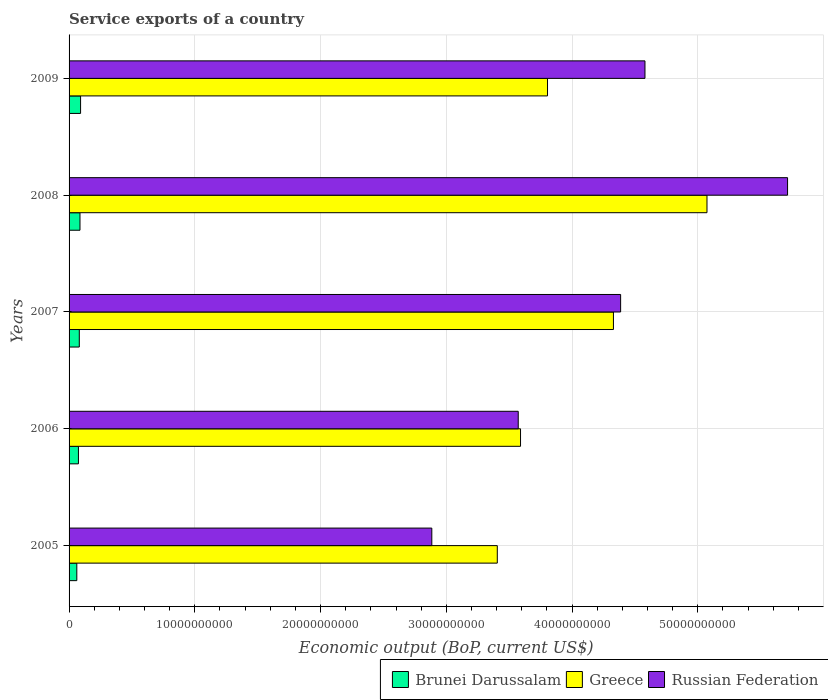How many different coloured bars are there?
Provide a short and direct response. 3. How many bars are there on the 1st tick from the bottom?
Ensure brevity in your answer.  3. In how many cases, is the number of bars for a given year not equal to the number of legend labels?
Offer a terse response. 0. What is the service exports in Greece in 2009?
Your answer should be very brief. 3.80e+1. Across all years, what is the maximum service exports in Greece?
Your response must be concise. 5.07e+1. Across all years, what is the minimum service exports in Brunei Darussalam?
Provide a short and direct response. 6.16e+08. What is the total service exports in Brunei Darussalam in the graph?
Give a very brief answer. 3.96e+09. What is the difference between the service exports in Russian Federation in 2005 and that in 2009?
Make the answer very short. -1.70e+1. What is the difference between the service exports in Russian Federation in 2005 and the service exports in Brunei Darussalam in 2009?
Ensure brevity in your answer.  2.79e+1. What is the average service exports in Brunei Darussalam per year?
Give a very brief answer. 7.91e+08. In the year 2006, what is the difference between the service exports in Brunei Darussalam and service exports in Russian Federation?
Give a very brief answer. -3.50e+1. What is the ratio of the service exports in Brunei Darussalam in 2006 to that in 2009?
Your answer should be very brief. 0.81. Is the service exports in Russian Federation in 2005 less than that in 2006?
Your answer should be compact. Yes. Is the difference between the service exports in Brunei Darussalam in 2008 and 2009 greater than the difference between the service exports in Russian Federation in 2008 and 2009?
Give a very brief answer. No. What is the difference between the highest and the second highest service exports in Brunei Darussalam?
Your response must be concise. 4.77e+07. What is the difference between the highest and the lowest service exports in Greece?
Your response must be concise. 1.67e+1. In how many years, is the service exports in Russian Federation greater than the average service exports in Russian Federation taken over all years?
Keep it short and to the point. 3. Is the sum of the service exports in Russian Federation in 2005 and 2007 greater than the maximum service exports in Greece across all years?
Offer a very short reply. Yes. What does the 1st bar from the top in 2008 represents?
Give a very brief answer. Russian Federation. What does the 3rd bar from the bottom in 2007 represents?
Make the answer very short. Russian Federation. Is it the case that in every year, the sum of the service exports in Brunei Darussalam and service exports in Russian Federation is greater than the service exports in Greece?
Your answer should be very brief. No. How many bars are there?
Keep it short and to the point. 15. Are all the bars in the graph horizontal?
Make the answer very short. Yes. Does the graph contain any zero values?
Give a very brief answer. No. What is the title of the graph?
Your response must be concise. Service exports of a country. Does "Canada" appear as one of the legend labels in the graph?
Offer a very short reply. No. What is the label or title of the X-axis?
Give a very brief answer. Economic output (BoP, current US$). What is the Economic output (BoP, current US$) in Brunei Darussalam in 2005?
Your response must be concise. 6.16e+08. What is the Economic output (BoP, current US$) of Greece in 2005?
Your answer should be compact. 3.41e+1. What is the Economic output (BoP, current US$) of Russian Federation in 2005?
Ensure brevity in your answer.  2.88e+1. What is the Economic output (BoP, current US$) in Brunei Darussalam in 2006?
Offer a very short reply. 7.45e+08. What is the Economic output (BoP, current US$) in Greece in 2006?
Your answer should be compact. 3.59e+1. What is the Economic output (BoP, current US$) in Russian Federation in 2006?
Your answer should be very brief. 3.57e+1. What is the Economic output (BoP, current US$) of Brunei Darussalam in 2007?
Your answer should be very brief. 8.13e+08. What is the Economic output (BoP, current US$) of Greece in 2007?
Provide a short and direct response. 4.33e+1. What is the Economic output (BoP, current US$) in Russian Federation in 2007?
Your answer should be very brief. 4.39e+1. What is the Economic output (BoP, current US$) of Brunei Darussalam in 2008?
Make the answer very short. 8.67e+08. What is the Economic output (BoP, current US$) in Greece in 2008?
Give a very brief answer. 5.07e+1. What is the Economic output (BoP, current US$) in Russian Federation in 2008?
Your response must be concise. 5.71e+1. What is the Economic output (BoP, current US$) in Brunei Darussalam in 2009?
Your response must be concise. 9.15e+08. What is the Economic output (BoP, current US$) in Greece in 2009?
Keep it short and to the point. 3.80e+1. What is the Economic output (BoP, current US$) of Russian Federation in 2009?
Provide a short and direct response. 4.58e+1. Across all years, what is the maximum Economic output (BoP, current US$) of Brunei Darussalam?
Provide a succinct answer. 9.15e+08. Across all years, what is the maximum Economic output (BoP, current US$) in Greece?
Provide a short and direct response. 5.07e+1. Across all years, what is the maximum Economic output (BoP, current US$) of Russian Federation?
Offer a terse response. 5.71e+1. Across all years, what is the minimum Economic output (BoP, current US$) in Brunei Darussalam?
Offer a terse response. 6.16e+08. Across all years, what is the minimum Economic output (BoP, current US$) in Greece?
Ensure brevity in your answer.  3.41e+1. Across all years, what is the minimum Economic output (BoP, current US$) of Russian Federation?
Provide a succinct answer. 2.88e+1. What is the total Economic output (BoP, current US$) of Brunei Darussalam in the graph?
Offer a terse response. 3.96e+09. What is the total Economic output (BoP, current US$) of Greece in the graph?
Provide a succinct answer. 2.02e+11. What is the total Economic output (BoP, current US$) in Russian Federation in the graph?
Your answer should be compact. 2.11e+11. What is the difference between the Economic output (BoP, current US$) in Brunei Darussalam in 2005 and that in 2006?
Provide a succinct answer. -1.28e+08. What is the difference between the Economic output (BoP, current US$) in Greece in 2005 and that in 2006?
Provide a short and direct response. -1.85e+09. What is the difference between the Economic output (BoP, current US$) in Russian Federation in 2005 and that in 2006?
Provide a short and direct response. -6.87e+09. What is the difference between the Economic output (BoP, current US$) of Brunei Darussalam in 2005 and that in 2007?
Provide a succinct answer. -1.97e+08. What is the difference between the Economic output (BoP, current US$) in Greece in 2005 and that in 2007?
Offer a terse response. -9.24e+09. What is the difference between the Economic output (BoP, current US$) of Russian Federation in 2005 and that in 2007?
Your answer should be compact. -1.50e+1. What is the difference between the Economic output (BoP, current US$) in Brunei Darussalam in 2005 and that in 2008?
Your answer should be compact. -2.51e+08. What is the difference between the Economic output (BoP, current US$) of Greece in 2005 and that in 2008?
Provide a short and direct response. -1.67e+1. What is the difference between the Economic output (BoP, current US$) of Russian Federation in 2005 and that in 2008?
Offer a very short reply. -2.83e+1. What is the difference between the Economic output (BoP, current US$) of Brunei Darussalam in 2005 and that in 2009?
Make the answer very short. -2.99e+08. What is the difference between the Economic output (BoP, current US$) in Greece in 2005 and that in 2009?
Keep it short and to the point. -3.99e+09. What is the difference between the Economic output (BoP, current US$) of Russian Federation in 2005 and that in 2009?
Give a very brief answer. -1.70e+1. What is the difference between the Economic output (BoP, current US$) of Brunei Darussalam in 2006 and that in 2007?
Keep it short and to the point. -6.88e+07. What is the difference between the Economic output (BoP, current US$) of Greece in 2006 and that in 2007?
Your answer should be very brief. -7.39e+09. What is the difference between the Economic output (BoP, current US$) of Russian Federation in 2006 and that in 2007?
Provide a short and direct response. -8.14e+09. What is the difference between the Economic output (BoP, current US$) in Brunei Darussalam in 2006 and that in 2008?
Your response must be concise. -1.23e+08. What is the difference between the Economic output (BoP, current US$) in Greece in 2006 and that in 2008?
Your answer should be very brief. -1.48e+1. What is the difference between the Economic output (BoP, current US$) of Russian Federation in 2006 and that in 2008?
Provide a succinct answer. -2.14e+1. What is the difference between the Economic output (BoP, current US$) of Brunei Darussalam in 2006 and that in 2009?
Your response must be concise. -1.70e+08. What is the difference between the Economic output (BoP, current US$) in Greece in 2006 and that in 2009?
Keep it short and to the point. -2.15e+09. What is the difference between the Economic output (BoP, current US$) in Russian Federation in 2006 and that in 2009?
Offer a terse response. -1.01e+1. What is the difference between the Economic output (BoP, current US$) of Brunei Darussalam in 2007 and that in 2008?
Give a very brief answer. -5.39e+07. What is the difference between the Economic output (BoP, current US$) in Greece in 2007 and that in 2008?
Your answer should be very brief. -7.44e+09. What is the difference between the Economic output (BoP, current US$) in Russian Federation in 2007 and that in 2008?
Offer a terse response. -1.33e+1. What is the difference between the Economic output (BoP, current US$) in Brunei Darussalam in 2007 and that in 2009?
Make the answer very short. -1.02e+08. What is the difference between the Economic output (BoP, current US$) of Greece in 2007 and that in 2009?
Provide a short and direct response. 5.24e+09. What is the difference between the Economic output (BoP, current US$) of Russian Federation in 2007 and that in 2009?
Keep it short and to the point. -1.94e+09. What is the difference between the Economic output (BoP, current US$) of Brunei Darussalam in 2008 and that in 2009?
Keep it short and to the point. -4.77e+07. What is the difference between the Economic output (BoP, current US$) of Greece in 2008 and that in 2009?
Your answer should be compact. 1.27e+1. What is the difference between the Economic output (BoP, current US$) of Russian Federation in 2008 and that in 2009?
Offer a terse response. 1.13e+1. What is the difference between the Economic output (BoP, current US$) of Brunei Darussalam in 2005 and the Economic output (BoP, current US$) of Greece in 2006?
Your response must be concise. -3.53e+1. What is the difference between the Economic output (BoP, current US$) of Brunei Darussalam in 2005 and the Economic output (BoP, current US$) of Russian Federation in 2006?
Your response must be concise. -3.51e+1. What is the difference between the Economic output (BoP, current US$) in Greece in 2005 and the Economic output (BoP, current US$) in Russian Federation in 2006?
Make the answer very short. -1.67e+09. What is the difference between the Economic output (BoP, current US$) in Brunei Darussalam in 2005 and the Economic output (BoP, current US$) in Greece in 2007?
Make the answer very short. -4.27e+1. What is the difference between the Economic output (BoP, current US$) in Brunei Darussalam in 2005 and the Economic output (BoP, current US$) in Russian Federation in 2007?
Your answer should be very brief. -4.32e+1. What is the difference between the Economic output (BoP, current US$) in Greece in 2005 and the Economic output (BoP, current US$) in Russian Federation in 2007?
Provide a succinct answer. -9.81e+09. What is the difference between the Economic output (BoP, current US$) in Brunei Darussalam in 2005 and the Economic output (BoP, current US$) in Greece in 2008?
Keep it short and to the point. -5.01e+1. What is the difference between the Economic output (BoP, current US$) in Brunei Darussalam in 2005 and the Economic output (BoP, current US$) in Russian Federation in 2008?
Ensure brevity in your answer.  -5.65e+1. What is the difference between the Economic output (BoP, current US$) in Greece in 2005 and the Economic output (BoP, current US$) in Russian Federation in 2008?
Give a very brief answer. -2.31e+1. What is the difference between the Economic output (BoP, current US$) of Brunei Darussalam in 2005 and the Economic output (BoP, current US$) of Greece in 2009?
Your response must be concise. -3.74e+1. What is the difference between the Economic output (BoP, current US$) in Brunei Darussalam in 2005 and the Economic output (BoP, current US$) in Russian Federation in 2009?
Keep it short and to the point. -4.52e+1. What is the difference between the Economic output (BoP, current US$) in Greece in 2005 and the Economic output (BoP, current US$) in Russian Federation in 2009?
Provide a succinct answer. -1.17e+1. What is the difference between the Economic output (BoP, current US$) in Brunei Darussalam in 2006 and the Economic output (BoP, current US$) in Greece in 2007?
Keep it short and to the point. -4.25e+1. What is the difference between the Economic output (BoP, current US$) of Brunei Darussalam in 2006 and the Economic output (BoP, current US$) of Russian Federation in 2007?
Offer a very short reply. -4.31e+1. What is the difference between the Economic output (BoP, current US$) of Greece in 2006 and the Economic output (BoP, current US$) of Russian Federation in 2007?
Your response must be concise. -7.96e+09. What is the difference between the Economic output (BoP, current US$) of Brunei Darussalam in 2006 and the Economic output (BoP, current US$) of Greece in 2008?
Your answer should be compact. -5.00e+1. What is the difference between the Economic output (BoP, current US$) of Brunei Darussalam in 2006 and the Economic output (BoP, current US$) of Russian Federation in 2008?
Offer a terse response. -5.64e+1. What is the difference between the Economic output (BoP, current US$) in Greece in 2006 and the Economic output (BoP, current US$) in Russian Federation in 2008?
Provide a short and direct response. -2.12e+1. What is the difference between the Economic output (BoP, current US$) of Brunei Darussalam in 2006 and the Economic output (BoP, current US$) of Greece in 2009?
Your answer should be very brief. -3.73e+1. What is the difference between the Economic output (BoP, current US$) in Brunei Darussalam in 2006 and the Economic output (BoP, current US$) in Russian Federation in 2009?
Your response must be concise. -4.51e+1. What is the difference between the Economic output (BoP, current US$) of Greece in 2006 and the Economic output (BoP, current US$) of Russian Federation in 2009?
Ensure brevity in your answer.  -9.90e+09. What is the difference between the Economic output (BoP, current US$) of Brunei Darussalam in 2007 and the Economic output (BoP, current US$) of Greece in 2008?
Ensure brevity in your answer.  -4.99e+1. What is the difference between the Economic output (BoP, current US$) of Brunei Darussalam in 2007 and the Economic output (BoP, current US$) of Russian Federation in 2008?
Ensure brevity in your answer.  -5.63e+1. What is the difference between the Economic output (BoP, current US$) of Greece in 2007 and the Economic output (BoP, current US$) of Russian Federation in 2008?
Keep it short and to the point. -1.38e+1. What is the difference between the Economic output (BoP, current US$) in Brunei Darussalam in 2007 and the Economic output (BoP, current US$) in Greece in 2009?
Give a very brief answer. -3.72e+1. What is the difference between the Economic output (BoP, current US$) of Brunei Darussalam in 2007 and the Economic output (BoP, current US$) of Russian Federation in 2009?
Your answer should be very brief. -4.50e+1. What is the difference between the Economic output (BoP, current US$) of Greece in 2007 and the Economic output (BoP, current US$) of Russian Federation in 2009?
Give a very brief answer. -2.51e+09. What is the difference between the Economic output (BoP, current US$) of Brunei Darussalam in 2008 and the Economic output (BoP, current US$) of Greece in 2009?
Make the answer very short. -3.72e+1. What is the difference between the Economic output (BoP, current US$) of Brunei Darussalam in 2008 and the Economic output (BoP, current US$) of Russian Federation in 2009?
Provide a succinct answer. -4.49e+1. What is the difference between the Economic output (BoP, current US$) of Greece in 2008 and the Economic output (BoP, current US$) of Russian Federation in 2009?
Keep it short and to the point. 4.93e+09. What is the average Economic output (BoP, current US$) of Brunei Darussalam per year?
Ensure brevity in your answer.  7.91e+08. What is the average Economic output (BoP, current US$) of Greece per year?
Your answer should be compact. 4.04e+1. What is the average Economic output (BoP, current US$) of Russian Federation per year?
Provide a short and direct response. 4.23e+1. In the year 2005, what is the difference between the Economic output (BoP, current US$) of Brunei Darussalam and Economic output (BoP, current US$) of Greece?
Your response must be concise. -3.34e+1. In the year 2005, what is the difference between the Economic output (BoP, current US$) in Brunei Darussalam and Economic output (BoP, current US$) in Russian Federation?
Provide a succinct answer. -2.82e+1. In the year 2005, what is the difference between the Economic output (BoP, current US$) in Greece and Economic output (BoP, current US$) in Russian Federation?
Offer a very short reply. 5.21e+09. In the year 2006, what is the difference between the Economic output (BoP, current US$) of Brunei Darussalam and Economic output (BoP, current US$) of Greece?
Keep it short and to the point. -3.52e+1. In the year 2006, what is the difference between the Economic output (BoP, current US$) of Brunei Darussalam and Economic output (BoP, current US$) of Russian Federation?
Ensure brevity in your answer.  -3.50e+1. In the year 2006, what is the difference between the Economic output (BoP, current US$) of Greece and Economic output (BoP, current US$) of Russian Federation?
Your answer should be compact. 1.82e+08. In the year 2007, what is the difference between the Economic output (BoP, current US$) in Brunei Darussalam and Economic output (BoP, current US$) in Greece?
Provide a short and direct response. -4.25e+1. In the year 2007, what is the difference between the Economic output (BoP, current US$) of Brunei Darussalam and Economic output (BoP, current US$) of Russian Federation?
Offer a very short reply. -4.30e+1. In the year 2007, what is the difference between the Economic output (BoP, current US$) in Greece and Economic output (BoP, current US$) in Russian Federation?
Your answer should be very brief. -5.71e+08. In the year 2008, what is the difference between the Economic output (BoP, current US$) in Brunei Darussalam and Economic output (BoP, current US$) in Greece?
Offer a terse response. -4.99e+1. In the year 2008, what is the difference between the Economic output (BoP, current US$) of Brunei Darussalam and Economic output (BoP, current US$) of Russian Federation?
Provide a short and direct response. -5.63e+1. In the year 2008, what is the difference between the Economic output (BoP, current US$) of Greece and Economic output (BoP, current US$) of Russian Federation?
Your response must be concise. -6.41e+09. In the year 2009, what is the difference between the Economic output (BoP, current US$) in Brunei Darussalam and Economic output (BoP, current US$) in Greece?
Your response must be concise. -3.71e+1. In the year 2009, what is the difference between the Economic output (BoP, current US$) in Brunei Darussalam and Economic output (BoP, current US$) in Russian Federation?
Offer a terse response. -4.49e+1. In the year 2009, what is the difference between the Economic output (BoP, current US$) in Greece and Economic output (BoP, current US$) in Russian Federation?
Offer a very short reply. -7.75e+09. What is the ratio of the Economic output (BoP, current US$) of Brunei Darussalam in 2005 to that in 2006?
Give a very brief answer. 0.83. What is the ratio of the Economic output (BoP, current US$) in Greece in 2005 to that in 2006?
Provide a short and direct response. 0.95. What is the ratio of the Economic output (BoP, current US$) of Russian Federation in 2005 to that in 2006?
Offer a very short reply. 0.81. What is the ratio of the Economic output (BoP, current US$) of Brunei Darussalam in 2005 to that in 2007?
Give a very brief answer. 0.76. What is the ratio of the Economic output (BoP, current US$) of Greece in 2005 to that in 2007?
Keep it short and to the point. 0.79. What is the ratio of the Economic output (BoP, current US$) of Russian Federation in 2005 to that in 2007?
Provide a short and direct response. 0.66. What is the ratio of the Economic output (BoP, current US$) of Brunei Darussalam in 2005 to that in 2008?
Offer a terse response. 0.71. What is the ratio of the Economic output (BoP, current US$) in Greece in 2005 to that in 2008?
Provide a succinct answer. 0.67. What is the ratio of the Economic output (BoP, current US$) of Russian Federation in 2005 to that in 2008?
Make the answer very short. 0.5. What is the ratio of the Economic output (BoP, current US$) of Brunei Darussalam in 2005 to that in 2009?
Provide a succinct answer. 0.67. What is the ratio of the Economic output (BoP, current US$) of Greece in 2005 to that in 2009?
Keep it short and to the point. 0.9. What is the ratio of the Economic output (BoP, current US$) of Russian Federation in 2005 to that in 2009?
Offer a terse response. 0.63. What is the ratio of the Economic output (BoP, current US$) of Brunei Darussalam in 2006 to that in 2007?
Give a very brief answer. 0.92. What is the ratio of the Economic output (BoP, current US$) of Greece in 2006 to that in 2007?
Your response must be concise. 0.83. What is the ratio of the Economic output (BoP, current US$) of Russian Federation in 2006 to that in 2007?
Provide a short and direct response. 0.81. What is the ratio of the Economic output (BoP, current US$) in Brunei Darussalam in 2006 to that in 2008?
Offer a terse response. 0.86. What is the ratio of the Economic output (BoP, current US$) in Greece in 2006 to that in 2008?
Your answer should be very brief. 0.71. What is the ratio of the Economic output (BoP, current US$) in Russian Federation in 2006 to that in 2008?
Your answer should be very brief. 0.63. What is the ratio of the Economic output (BoP, current US$) in Brunei Darussalam in 2006 to that in 2009?
Your response must be concise. 0.81. What is the ratio of the Economic output (BoP, current US$) in Greece in 2006 to that in 2009?
Offer a very short reply. 0.94. What is the ratio of the Economic output (BoP, current US$) of Russian Federation in 2006 to that in 2009?
Keep it short and to the point. 0.78. What is the ratio of the Economic output (BoP, current US$) of Brunei Darussalam in 2007 to that in 2008?
Your answer should be very brief. 0.94. What is the ratio of the Economic output (BoP, current US$) of Greece in 2007 to that in 2008?
Make the answer very short. 0.85. What is the ratio of the Economic output (BoP, current US$) of Russian Federation in 2007 to that in 2008?
Provide a short and direct response. 0.77. What is the ratio of the Economic output (BoP, current US$) of Brunei Darussalam in 2007 to that in 2009?
Give a very brief answer. 0.89. What is the ratio of the Economic output (BoP, current US$) in Greece in 2007 to that in 2009?
Make the answer very short. 1.14. What is the ratio of the Economic output (BoP, current US$) of Russian Federation in 2007 to that in 2009?
Your response must be concise. 0.96. What is the ratio of the Economic output (BoP, current US$) of Brunei Darussalam in 2008 to that in 2009?
Your answer should be compact. 0.95. What is the ratio of the Economic output (BoP, current US$) of Greece in 2008 to that in 2009?
Your response must be concise. 1.33. What is the ratio of the Economic output (BoP, current US$) in Russian Federation in 2008 to that in 2009?
Give a very brief answer. 1.25. What is the difference between the highest and the second highest Economic output (BoP, current US$) in Brunei Darussalam?
Make the answer very short. 4.77e+07. What is the difference between the highest and the second highest Economic output (BoP, current US$) of Greece?
Your answer should be very brief. 7.44e+09. What is the difference between the highest and the second highest Economic output (BoP, current US$) in Russian Federation?
Give a very brief answer. 1.13e+1. What is the difference between the highest and the lowest Economic output (BoP, current US$) of Brunei Darussalam?
Offer a terse response. 2.99e+08. What is the difference between the highest and the lowest Economic output (BoP, current US$) of Greece?
Offer a very short reply. 1.67e+1. What is the difference between the highest and the lowest Economic output (BoP, current US$) of Russian Federation?
Make the answer very short. 2.83e+1. 